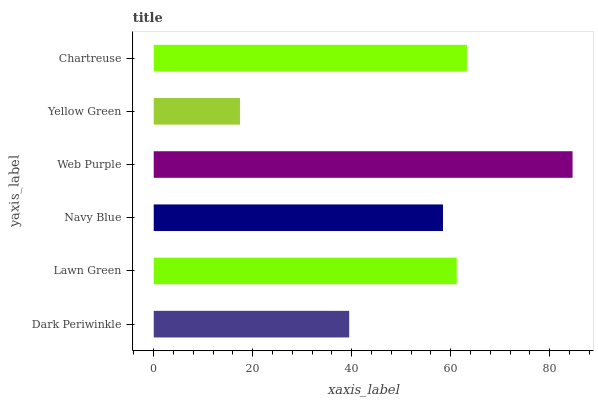Is Yellow Green the minimum?
Answer yes or no. Yes. Is Web Purple the maximum?
Answer yes or no. Yes. Is Lawn Green the minimum?
Answer yes or no. No. Is Lawn Green the maximum?
Answer yes or no. No. Is Lawn Green greater than Dark Periwinkle?
Answer yes or no. Yes. Is Dark Periwinkle less than Lawn Green?
Answer yes or no. Yes. Is Dark Periwinkle greater than Lawn Green?
Answer yes or no. No. Is Lawn Green less than Dark Periwinkle?
Answer yes or no. No. Is Lawn Green the high median?
Answer yes or no. Yes. Is Navy Blue the low median?
Answer yes or no. Yes. Is Navy Blue the high median?
Answer yes or no. No. Is Web Purple the low median?
Answer yes or no. No. 